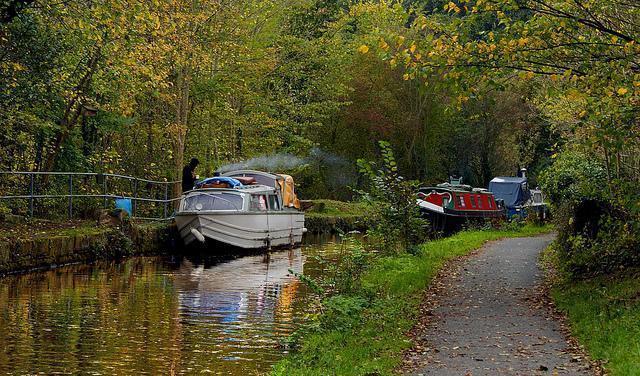What type byway is shown here?
Choose the correct response and explain in the format: 'Answer: answer
Rationale: rationale.'
Options: Freeway, raceway, nature path, railway. Answer: nature path.
Rationale: The byway is a nature path for hiking. 